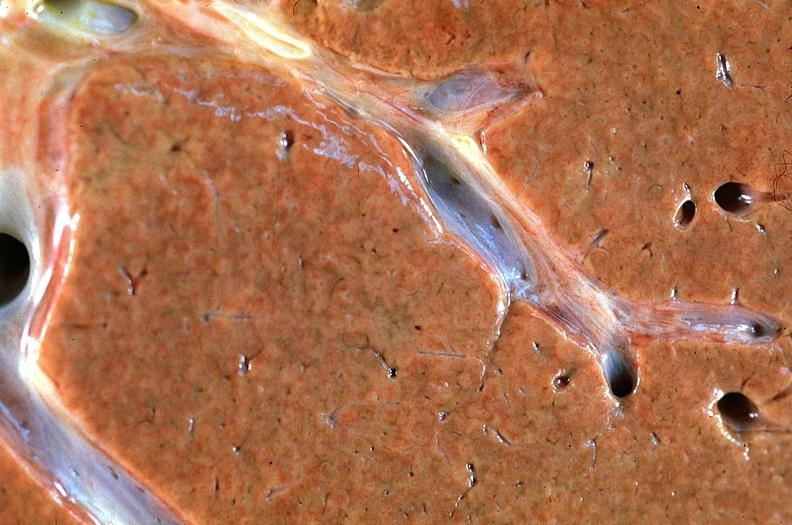s hepatobiliary present?
Answer the question using a single word or phrase. Yes 